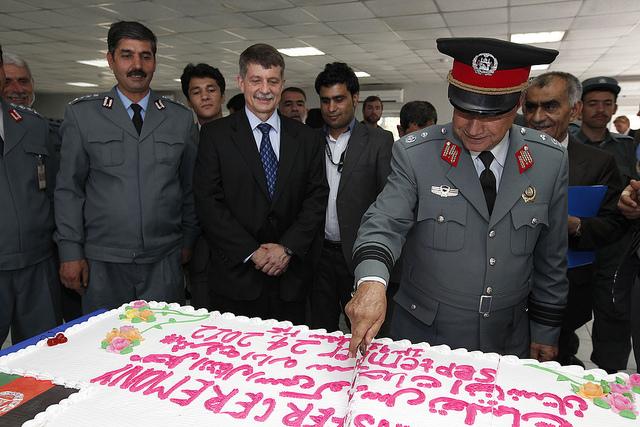What is the man cutting the cake wearing?
Quick response, please. Uniform. Has the cake been cut yet?
Quick response, please. No. Are there any women in the photo?
Keep it brief. No. What is this man cutting?
Concise answer only. Cake. Are there any woman around?
Give a very brief answer. No. 